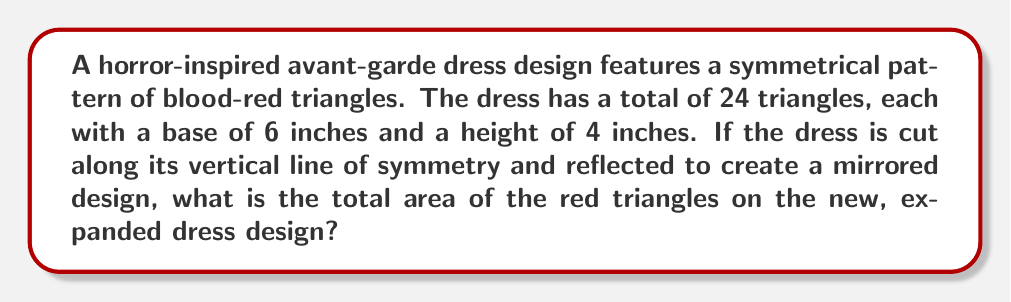What is the answer to this math problem? Let's approach this step-by-step:

1) First, we need to calculate the area of a single triangle:
   Area of a triangle = $\frac{1}{2} \times base \times height$
   $A = \frac{1}{2} \times 6 \times 4 = 12$ square inches

2) Now, we know there are 24 triangles in total on the original dress:
   Total area of triangles = $24 \times 12 = 288$ square inches

3) When the dress is cut along its line of symmetry and reflected, we're essentially doubling the design:
   New total number of triangles = $24 \times 2 = 48$

4) Therefore, the total area of the red triangles on the new, expanded dress design is:
   New total area = $48 \times 12 = 576$ square inches

This mirroring technique creates a symmetrical, visually striking design that doubles the impact of the original pattern, perfect for a horror-inspired avant-garde fashion piece.
Answer: 576 square inches 